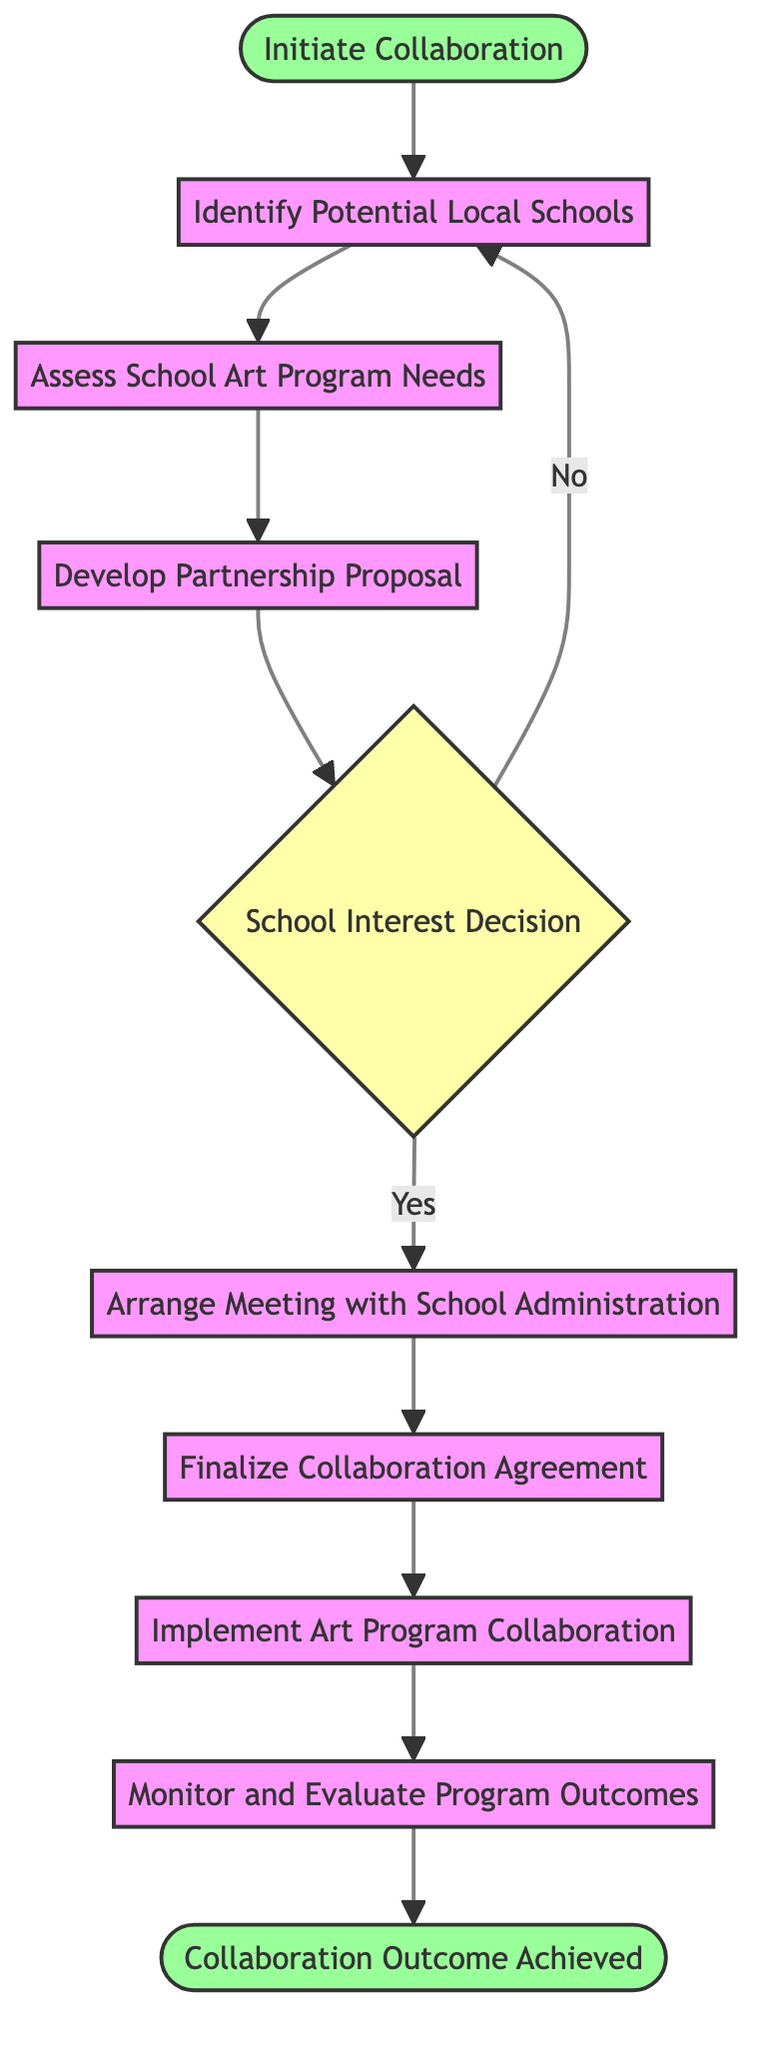What is the starting event in the diagram? The starting event is represented by the node labeled "Initiate Collaboration." It is the first element in the flow, from which all activities begin.
Answer: Initiate Collaboration How many activities are there in the diagram? The diagram includes six activities, denoted by distinct nodes that describe specific tasks or steps in the collaboration process.
Answer: 6 What happens after "Develop Partnership Proposal"? After "Develop Partnership Proposal," the next step is the decision node labeled "School Interest Decision," which determines the school's interest in the proposal.
Answer: School Interest Decision What do you do if the school is not interested in the proposal? If the school is not interested, the process loops back to "Identify Potential Local Schools," indicating that alternative schools may be considered for collaboration.
Answer: Identify Potential Local Schools Which activity comes just before "Finalize Collaboration Agreement"? The activity that comes just before "Finalize Collaboration Agreement" is "Arrange Meeting with School Administration," where the proposal is discussed with the school's administration.
Answer: Arrange Meeting with School Administration What is the final event in the diagram? The final event is labeled "Collaboration Outcome Achieved," marking the conclusion of the entire collaboration process once the program is successfully implemented.
Answer: Collaboration Outcome Achieved What decision is made at the "School Interest Decision" node? The decision made at this node is whether the school is interested in the proposal, determining the next steps in the collaboration process based on their response.
Answer: School Interest Decision What activity involves assessing the success of the collaboration? The activity that involves assessing the success of the collaboration is "Monitor and Evaluate Program Outcomes," where the outcomes and impacts are regularly reviewed.
Answer: Monitor and Evaluate Program Outcomes How are the activities connected in the process? The activities are connected in a sequential flow, where each leads to the next step, with a decision point that can loop back based on interest levels.
Answer: Sequential flow 